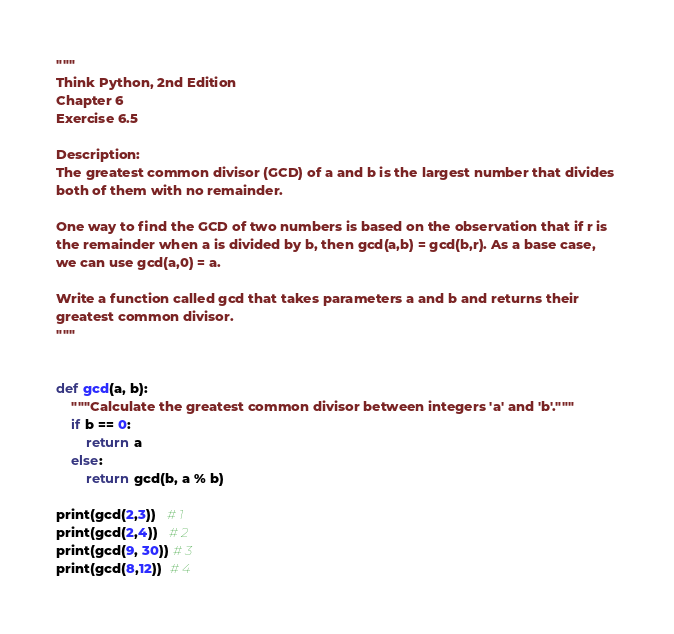Convert code to text. <code><loc_0><loc_0><loc_500><loc_500><_Python_>"""
Think Python, 2nd Edition
Chapter 6
Exercise 6.5

Description: 
The greatest common divisor (GCD) of a and b is the largest number that divides 
both of them with no remainder.

One way to find the GCD of two numbers is based on the observation that if r is 
the remainder when a is divided by b, then gcd(a,b) = gcd(b,r). As a base case, 
we can use gcd(a,0) = a.

Write a function called gcd that takes parameters a and b and returns their 
greatest common divisor.
"""


def gcd(a, b):
    """Calculate the greatest common divisor between integers 'a' and 'b'."""
    if b == 0:
        return a
    else:
        return gcd(b, a % b)

print(gcd(2,3))   # 1
print(gcd(2,4))   # 2
print(gcd(9, 30)) # 3
print(gcd(8,12))  # 4
</code> 